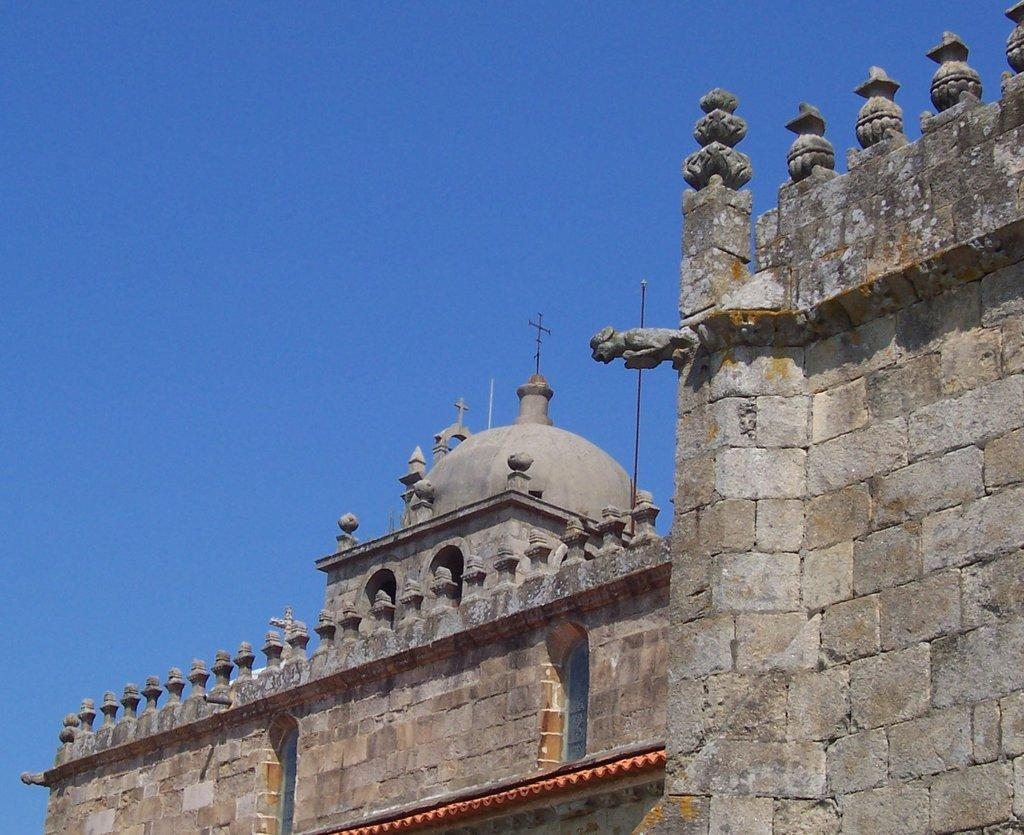What type of wall is featured on the building in the image? The building has a brick wall. What architectural elements can be seen on the building? The building has small pillars. What religious symbol is present on top of the building? There are crosses on top of the building. What can be seen in the background of the image? The sky is visible in the background. Can you see a tiger walking on the brick wall in the image? No, there is no tiger present in the image. What trick is being performed by the crosses on top of the building? There is no trick being performed by the crosses; they are simply religious symbols. 